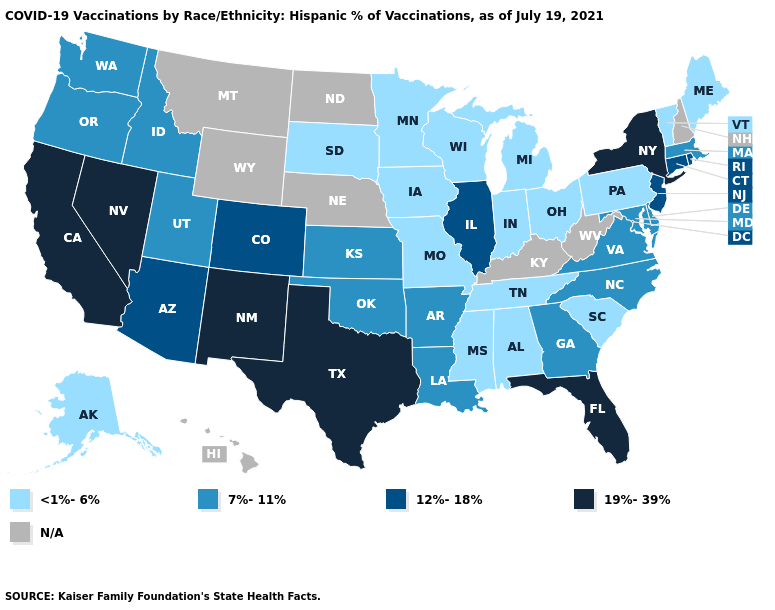What is the value of Rhode Island?
Keep it brief. 12%-18%. Does the map have missing data?
Answer briefly. Yes. What is the highest value in the South ?
Be succinct. 19%-39%. Among the states that border New Mexico , which have the lowest value?
Concise answer only. Oklahoma, Utah. Does Virginia have the lowest value in the USA?
Give a very brief answer. No. What is the value of Illinois?
Write a very short answer. 12%-18%. Among the states that border Mississippi , does Tennessee have the highest value?
Keep it brief. No. What is the value of Delaware?
Keep it brief. 7%-11%. Among the states that border Arkansas , which have the highest value?
Give a very brief answer. Texas. What is the highest value in states that border Pennsylvania?
Write a very short answer. 19%-39%. What is the value of Nevada?
Be succinct. 19%-39%. Does the map have missing data?
Give a very brief answer. Yes. Name the states that have a value in the range <1%-6%?
Answer briefly. Alabama, Alaska, Indiana, Iowa, Maine, Michigan, Minnesota, Mississippi, Missouri, Ohio, Pennsylvania, South Carolina, South Dakota, Tennessee, Vermont, Wisconsin. Among the states that border Washington , which have the highest value?
Concise answer only. Idaho, Oregon. Which states have the highest value in the USA?
Be succinct. California, Florida, Nevada, New Mexico, New York, Texas. 